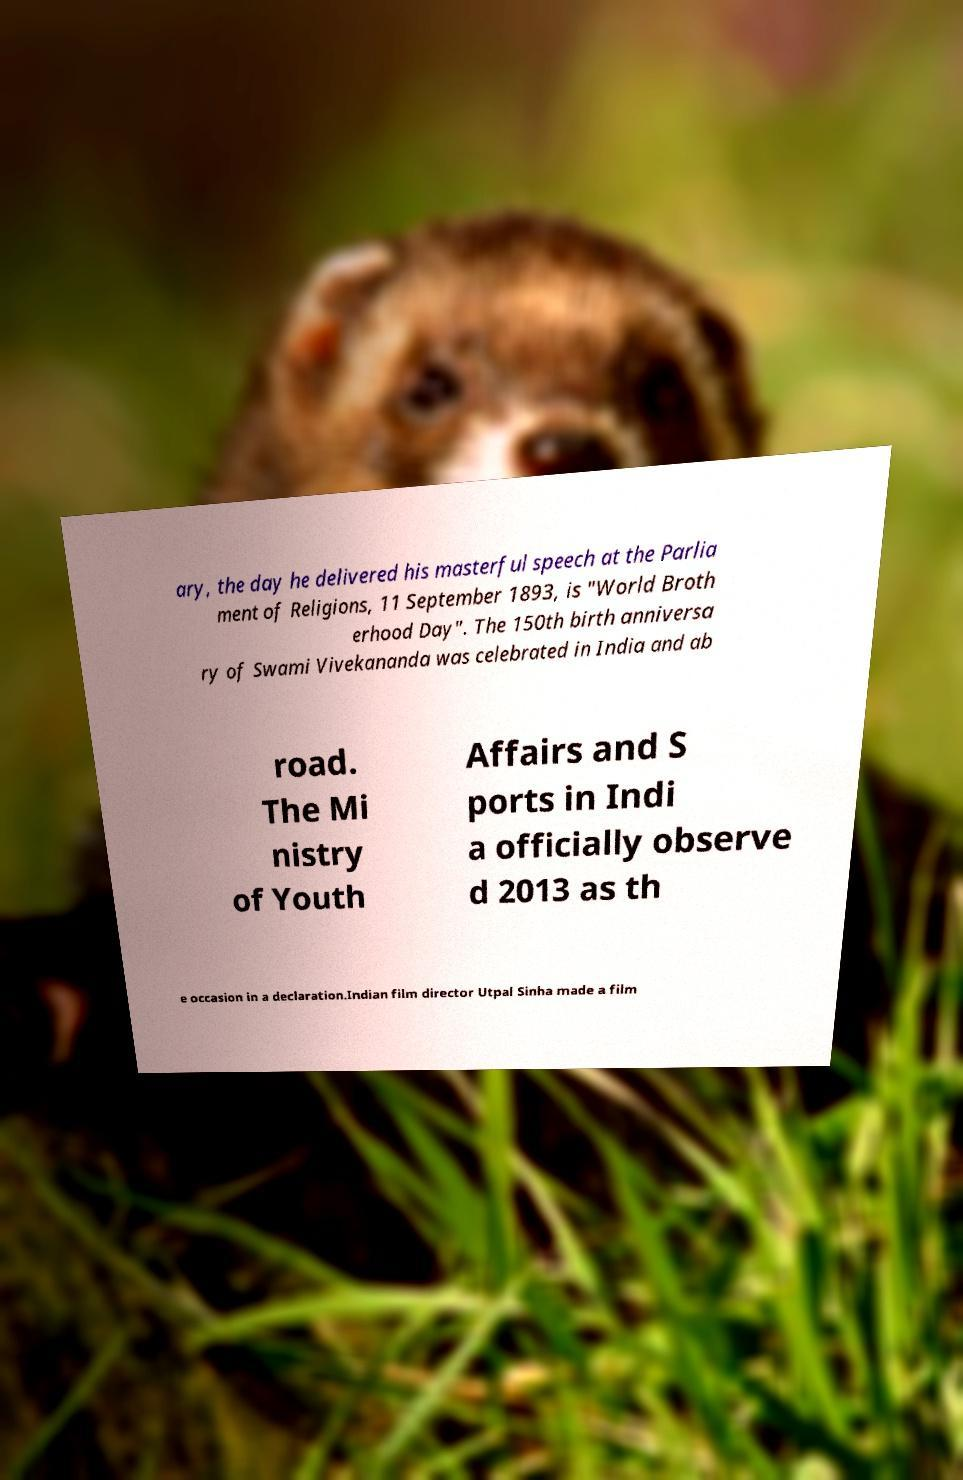Could you assist in decoding the text presented in this image and type it out clearly? ary, the day he delivered his masterful speech at the Parlia ment of Religions, 11 September 1893, is "World Broth erhood Day". The 150th birth anniversa ry of Swami Vivekananda was celebrated in India and ab road. The Mi nistry of Youth Affairs and S ports in Indi a officially observe d 2013 as th e occasion in a declaration.Indian film director Utpal Sinha made a film 